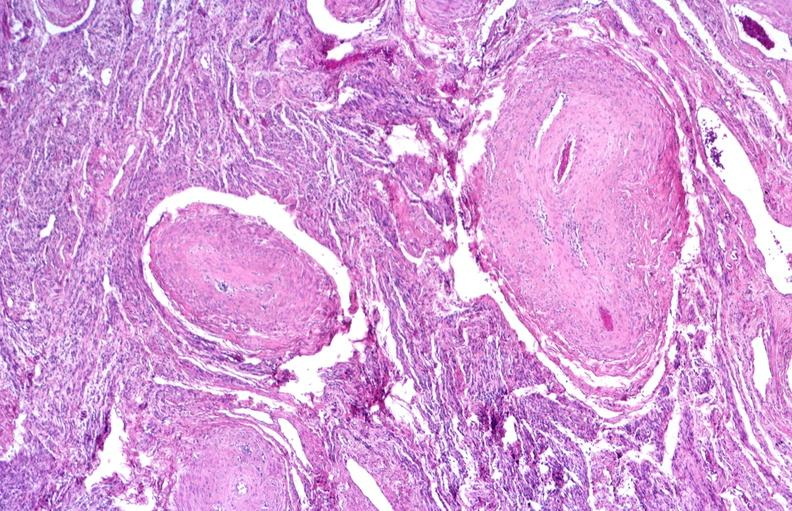does this image show kidney, polyarteritis nodosa?
Answer the question using a single word or phrase. Yes 